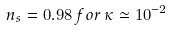<formula> <loc_0><loc_0><loc_500><loc_500>n _ { s } = 0 . 9 8 \, f o r \, \kappa \simeq 1 0 ^ { - 2 }</formula> 